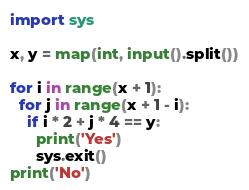Convert code to text. <code><loc_0><loc_0><loc_500><loc_500><_Python_>import sys
 
x, y = map(int, input().split())
 
for i in range(x + 1):
  for j in range(x + 1 - i):
    if i * 2 + j * 4 == y:
      print('Yes')
      sys.exit()
print('No')</code> 